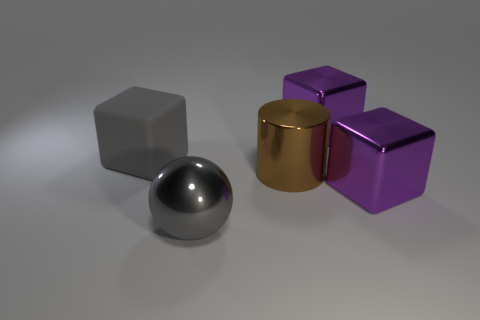Subtract all shiny blocks. How many blocks are left? 1 Subtract all cylinders. How many objects are left? 4 Subtract 2 cubes. How many cubes are left? 1 Subtract all gray cubes. How many cubes are left? 2 Subtract all brown metallic cylinders. Subtract all big brown objects. How many objects are left? 3 Add 5 large shiny blocks. How many large shiny blocks are left? 7 Add 4 gray spheres. How many gray spheres exist? 5 Add 5 brown objects. How many objects exist? 10 Subtract 0 brown spheres. How many objects are left? 5 Subtract all green cylinders. Subtract all yellow blocks. How many cylinders are left? 1 